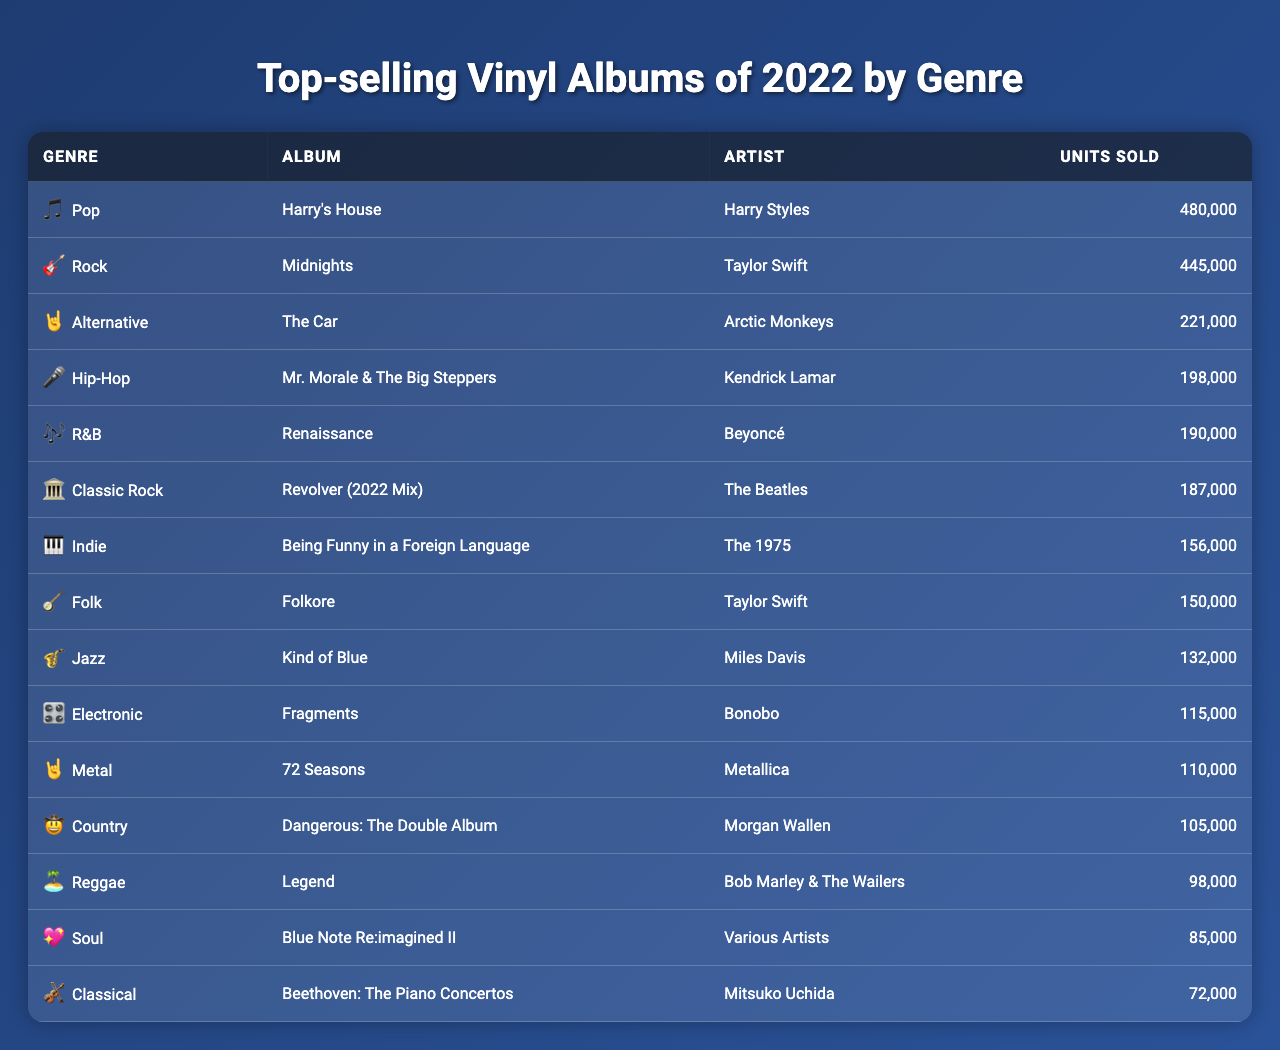What is the best-selling album in the Pop genre? The table lists "Harry's House" by Harry Styles as the best-selling album in the Pop genre with 480,000 units sold.
Answer: Harry's House Which album sold the most units overall? "Harry's House" by Harry Styles sold the most units, totaling 480,000.
Answer: 480,000 How many units did the second best-selling album in Rock sell? The second best-selling album in Rock is "Midnights" by Taylor Swift, which sold 445,000 units.
Answer: 445,000 Is "Folkore" by Taylor Swift a top-selling album in 2022? Yes, "Folkore" sold 150,000 units, making it one of the top-selling albums of 2022.
Answer: Yes What is the difference in units sold between the best-selling and the least-selling album? The best-selling album, "Harry's House," sold 480,000 units while the least-selling album, "Beethoven: The Piano Concertos," sold 72,000 units. Therefore, the difference is 480,000 - 72,000 = 408,000.
Answer: 408,000 Which genre had the least number of units sold by its top album? The Classical genre, represented by "Beethoven: The Piano Concertos," had the least number of units sold at 72,000.
Answer: Classical What is the average number of units sold for albums in the R&B and Hip-Hop genres? R&B (190,000 units for "Renaissance") and Hip-Hop (198,000 units for "Mr. Morale & The Big Steppers") are averaged: (190,000 + 198,000) / 2 = 194,000.
Answer: 194,000 How many albums sold more than 200,000 units? The albums that sold more than 200,000 units are "Harry's House," "Midnights," "The Car," and "Mr. Morale & The Big Steppers," totaling four albums.
Answer: 4 What genre does "Kind of Blue" belong to, and how many units did it sell? "Kind of Blue" belongs to the Jazz genre and sold 132,000 units.
Answer: Jazz, 132,000 Which artist has two albums in the top-selling list, and what are they? Taylor Swift has two albums in the top-selling list: "Midnights" (Rock) and "Folkore" (Folk).
Answer: Taylor Swift, Midnights and Folklore 